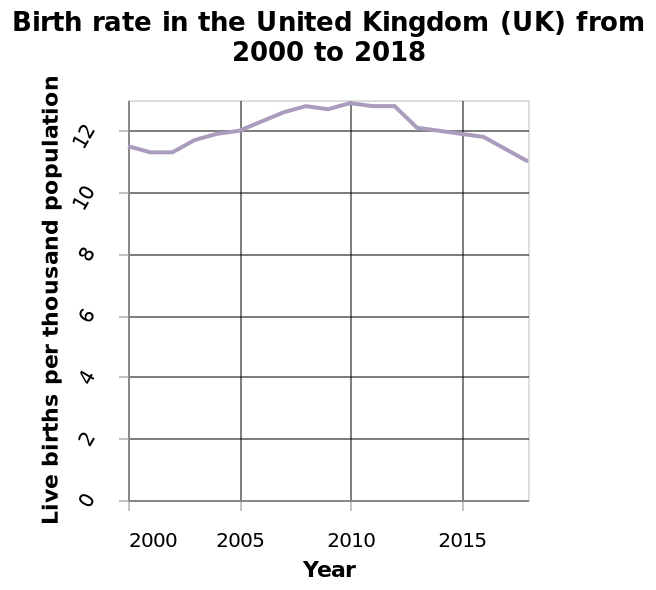<image>
What happened to the birth rate in the UK by 2015?  By 2015, the birth rate in the UK dropped. In which year does the birth rate line plot start? The birth rate line plot starts in the year 2000. Offer a thorough analysis of the image. Live months peaks around 2010 before returning to similar levels in 2015 as it did in 2005. please enumerates aspects of the construction of the chart Birth rate in the United Kingdom (UK) from 2000 to 2018 is a line plot. Year is defined as a linear scale with a minimum of 2000 and a maximum of 2015 on the x-axis. Live births per thousand population is measured as a linear scale with a minimum of 0 and a maximum of 12 along the y-axis. 